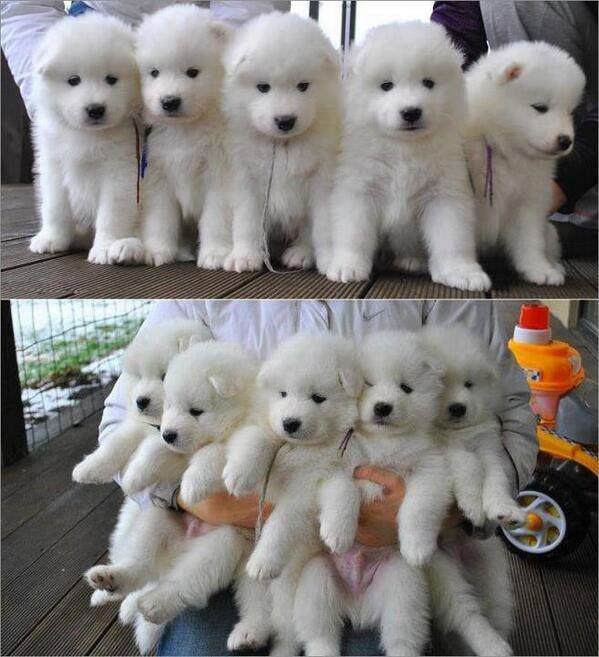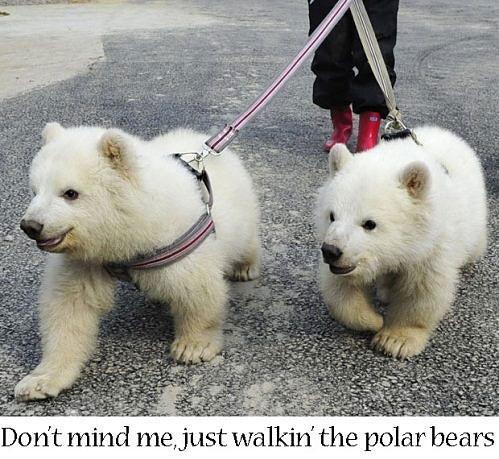The first image is the image on the left, the second image is the image on the right. Examine the images to the left and right. Is the description "Hands are holding up at least five white puppies in one image." accurate? Answer yes or no. Yes. The first image is the image on the left, the second image is the image on the right. Examine the images to the left and right. Is the description "There is no more than one white dog in the right image." accurate? Answer yes or no. No. 